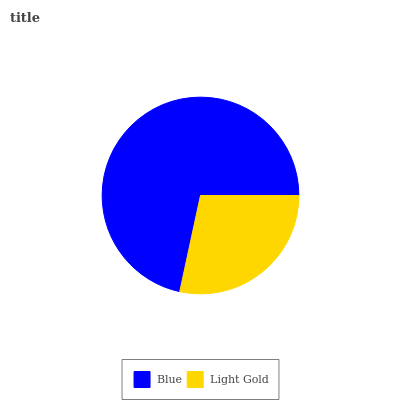Is Light Gold the minimum?
Answer yes or no. Yes. Is Blue the maximum?
Answer yes or no. Yes. Is Light Gold the maximum?
Answer yes or no. No. Is Blue greater than Light Gold?
Answer yes or no. Yes. Is Light Gold less than Blue?
Answer yes or no. Yes. Is Light Gold greater than Blue?
Answer yes or no. No. Is Blue less than Light Gold?
Answer yes or no. No. Is Blue the high median?
Answer yes or no. Yes. Is Light Gold the low median?
Answer yes or no. Yes. Is Light Gold the high median?
Answer yes or no. No. Is Blue the low median?
Answer yes or no. No. 